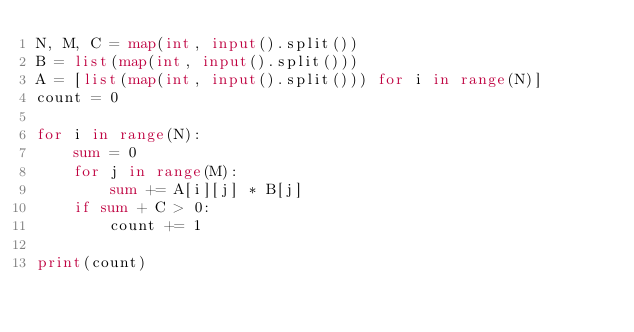Convert code to text. <code><loc_0><loc_0><loc_500><loc_500><_Python_>N, M, C = map(int, input().split())
B = list(map(int, input().split()))
A = [list(map(int, input().split())) for i in range(N)]
count = 0

for i in range(N):
    sum = 0
    for j in range(M):
        sum += A[i][j] * B[j]
    if sum + C > 0:
        count += 1

print(count)
</code> 